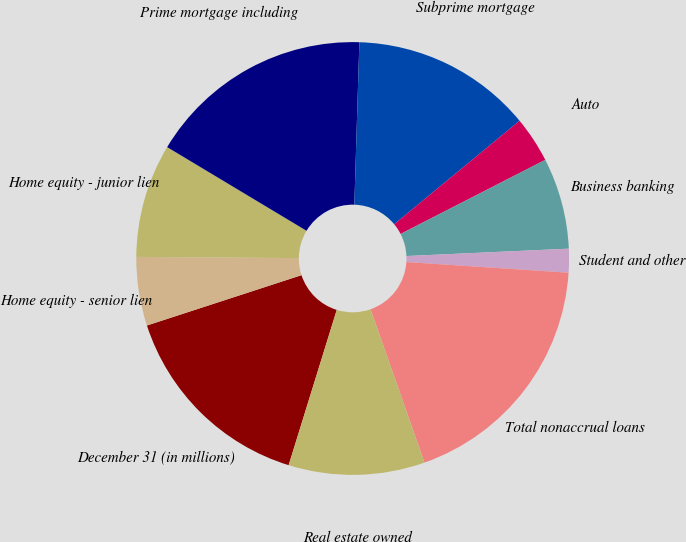Convert chart to OTSL. <chart><loc_0><loc_0><loc_500><loc_500><pie_chart><fcel>December 31 (in millions)<fcel>Home equity - senior lien<fcel>Home equity - junior lien<fcel>Prime mortgage including<fcel>Subprime mortgage<fcel>Auto<fcel>Business banking<fcel>Student and other<fcel>Total nonaccrual loans<fcel>Real estate owned<nl><fcel>15.21%<fcel>5.13%<fcel>8.49%<fcel>16.89%<fcel>13.53%<fcel>3.45%<fcel>6.81%<fcel>1.77%<fcel>18.57%<fcel>10.17%<nl></chart> 